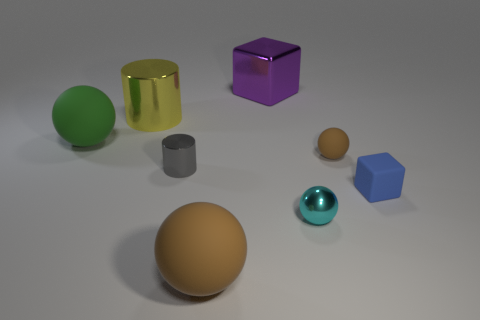Subtract all metallic spheres. How many spheres are left? 3 Subtract all brown spheres. How many spheres are left? 2 Subtract all cylinders. How many objects are left? 6 Add 2 tiny gray shiny cylinders. How many objects exist? 10 Subtract all green cylinders. How many brown balls are left? 2 Subtract 2 brown balls. How many objects are left? 6 Subtract 1 cylinders. How many cylinders are left? 1 Subtract all blue spheres. Subtract all cyan blocks. How many spheres are left? 4 Subtract all gray matte objects. Subtract all small gray metal objects. How many objects are left? 7 Add 6 brown objects. How many brown objects are left? 8 